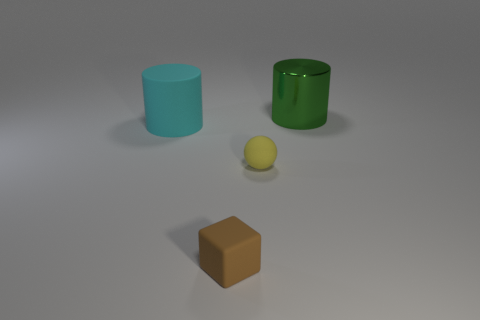Are there any other things that have the same shape as the yellow thing?
Your answer should be very brief. No. What material is the big thing left of the small matte object in front of the small yellow thing on the right side of the brown matte object?
Keep it short and to the point. Rubber. How many metal things are either gray objects or small brown things?
Your response must be concise. 0. Are there any other things that have the same material as the green object?
Your answer should be very brief. No. What number of things are matte things or big cylinders that are left of the brown rubber object?
Provide a short and direct response. 3. There is a cylinder that is on the right side of the sphere; is its size the same as the tiny brown matte object?
Provide a succinct answer. No. What number of other things are there of the same shape as the large metal thing?
Your response must be concise. 1. What number of yellow things are tiny matte balls or large rubber objects?
Ensure brevity in your answer.  1. What shape is the small brown thing that is made of the same material as the cyan cylinder?
Offer a very short reply. Cube. What is the color of the thing that is behind the sphere and on the right side of the cyan matte cylinder?
Make the answer very short. Green. 